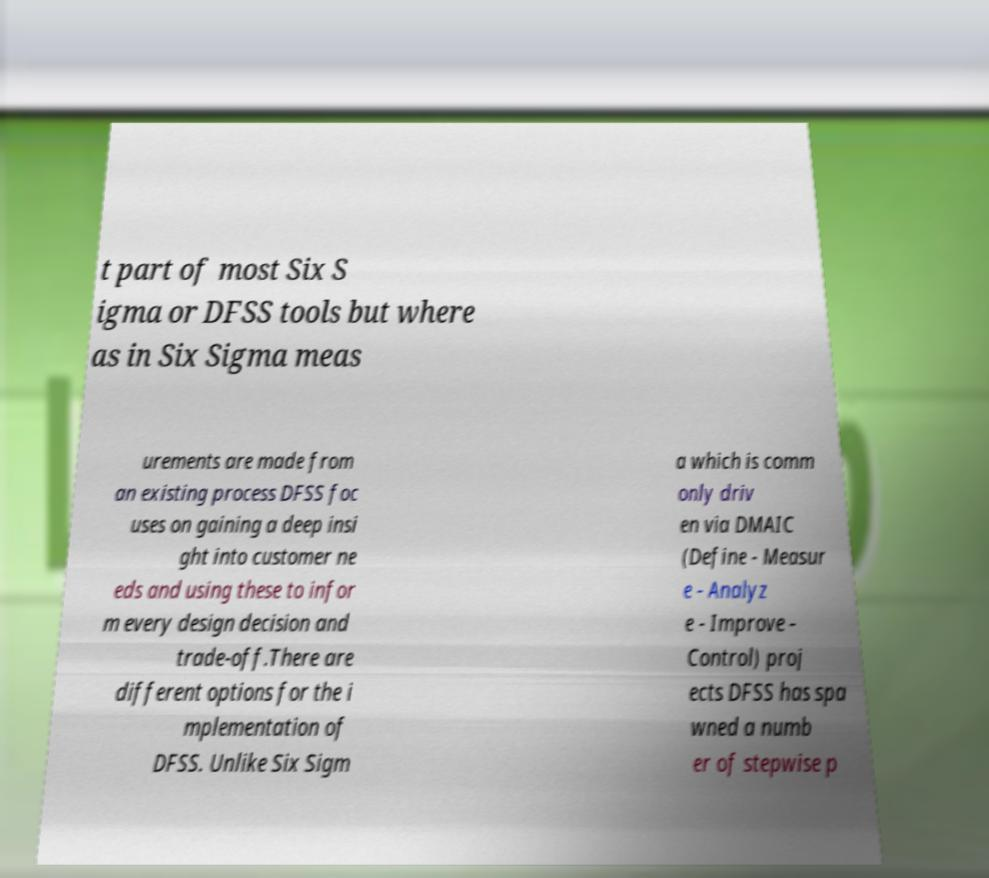Please identify and transcribe the text found in this image. t part of most Six S igma or DFSS tools but where as in Six Sigma meas urements are made from an existing process DFSS foc uses on gaining a deep insi ght into customer ne eds and using these to infor m every design decision and trade-off.There are different options for the i mplementation of DFSS. Unlike Six Sigm a which is comm only driv en via DMAIC (Define - Measur e - Analyz e - Improve - Control) proj ects DFSS has spa wned a numb er of stepwise p 